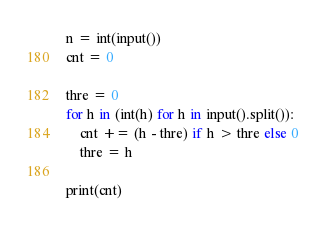Convert code to text. <code><loc_0><loc_0><loc_500><loc_500><_Python_>n = int(input())
cnt = 0

thre = 0
for h in (int(h) for h in input().split()):
    cnt += (h - thre) if h > thre else 0
    thre = h

print(cnt)</code> 